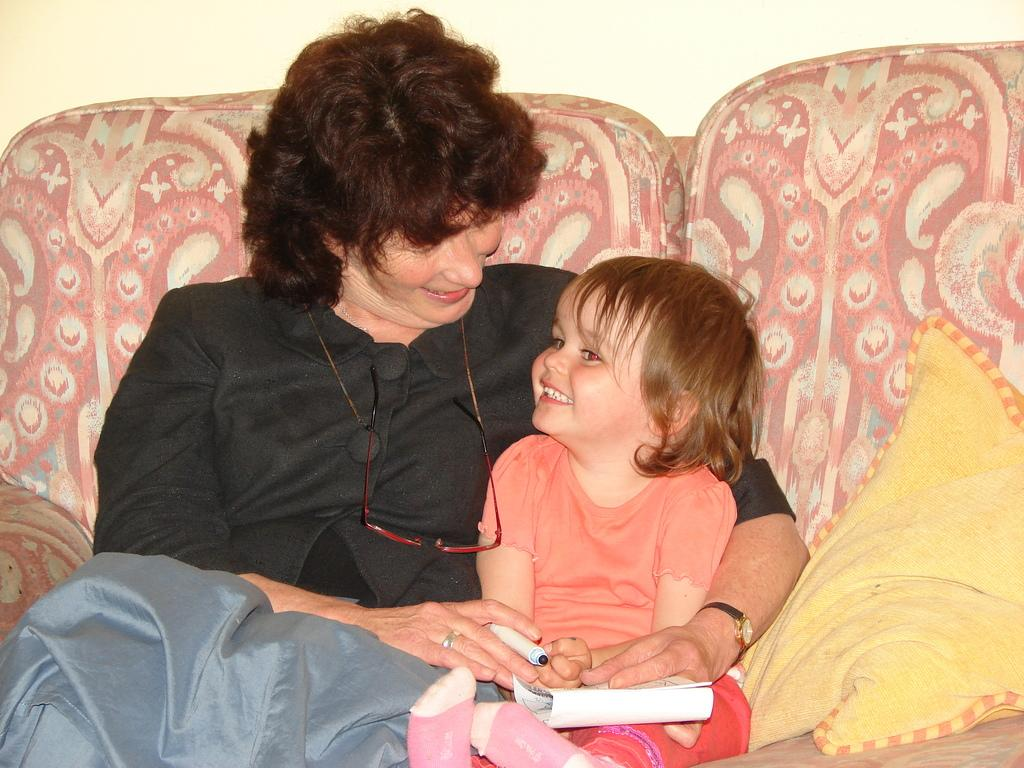How many people are sitting on the sofa in the image? There are two people sitting on the sofa in the image. What is the person on the left wearing? The person on the left is wearing a black dress. What is the person on the right holding? The person on the right is holding a book. Can you describe any details about the sofa? There is a yellow cushion on the right side of the sofa. What type of screw can be seen on the sidewalk in the image? There is no sidewalk or screw present in the image; it features two people sitting on a sofa. 